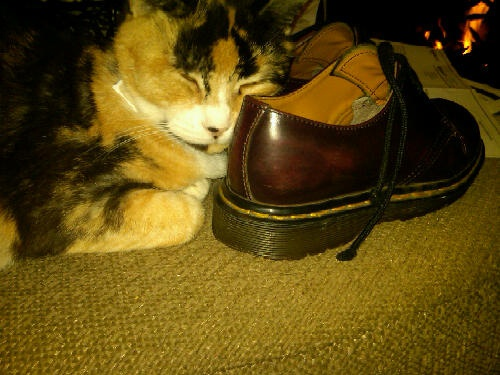Describe the objects in this image and their specific colors. I can see a cat in black and olive tones in this image. 